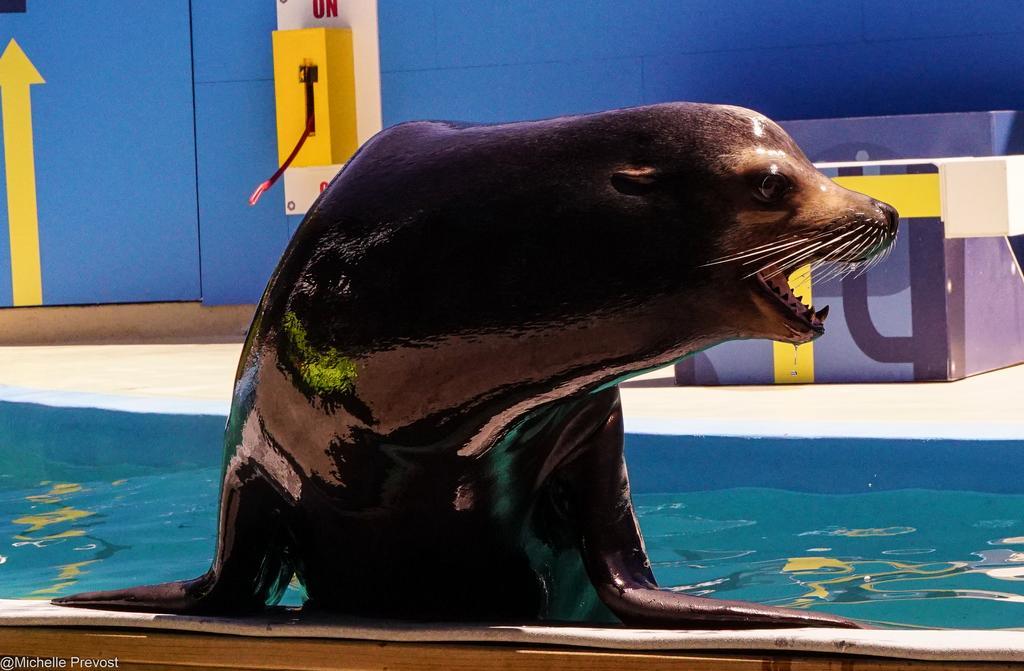Please provide a concise description of this image. In this image we can see water and a sea animal. In the background we can see wall and objects. 